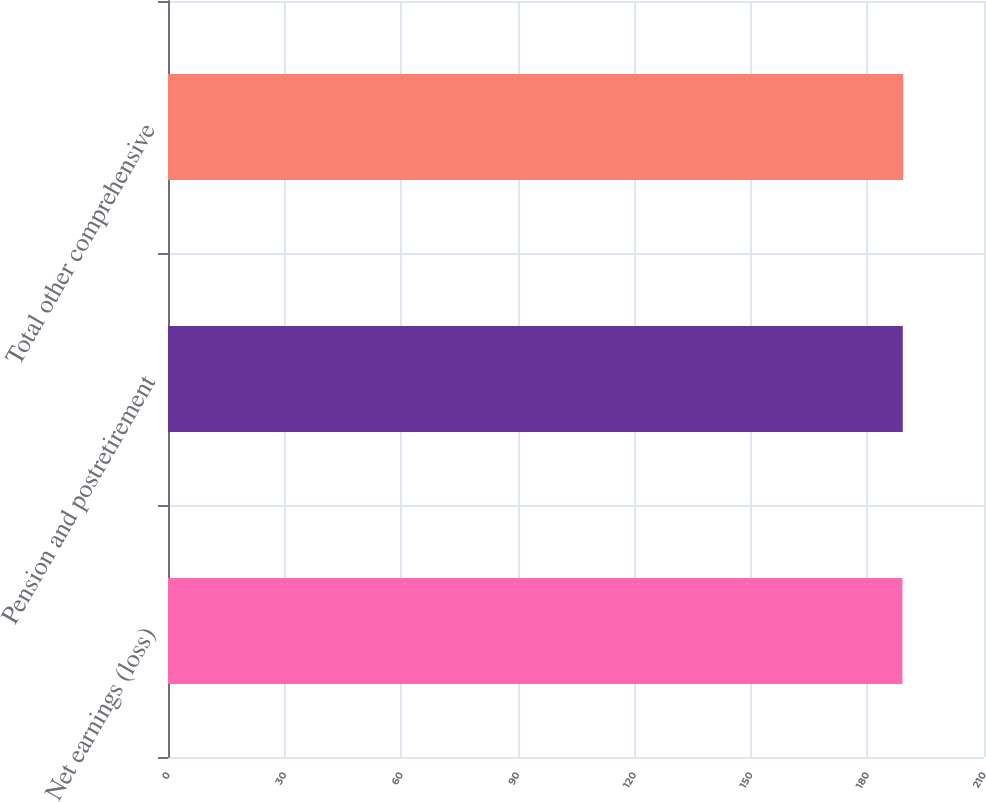<chart> <loc_0><loc_0><loc_500><loc_500><bar_chart><fcel>Net earnings (loss)<fcel>Pension and postretirement<fcel>Total other comprehensive<nl><fcel>189<fcel>189.1<fcel>189.2<nl></chart> 